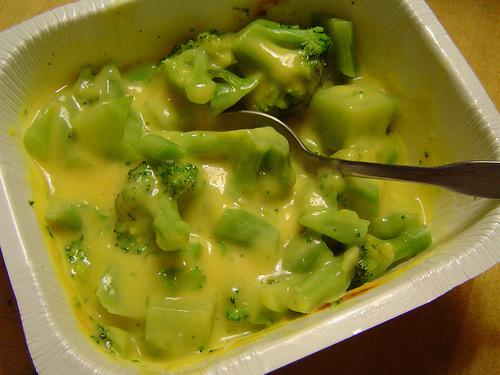How was this dish prepared? microwave 